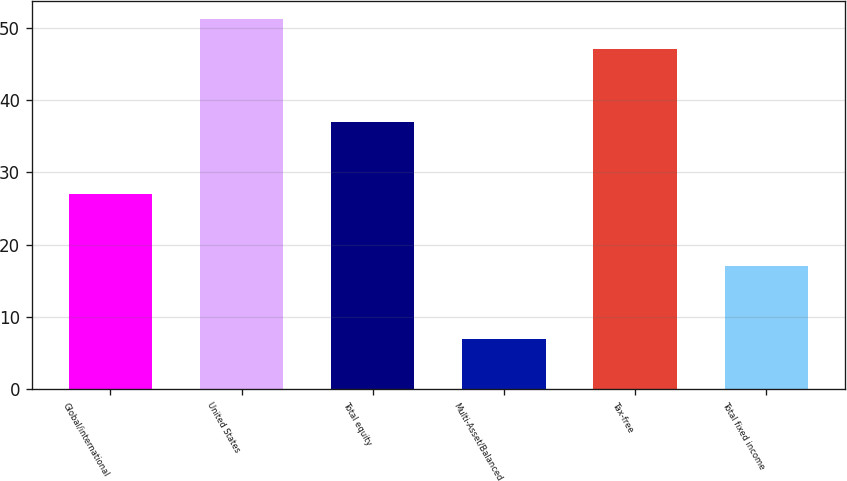Convert chart. <chart><loc_0><loc_0><loc_500><loc_500><bar_chart><fcel>Global/international<fcel>United States<fcel>Total equity<fcel>Multi-Asset/Balanced<fcel>Tax-free<fcel>Total fixed income<nl><fcel>27<fcel>51.2<fcel>37<fcel>7<fcel>47<fcel>17<nl></chart> 